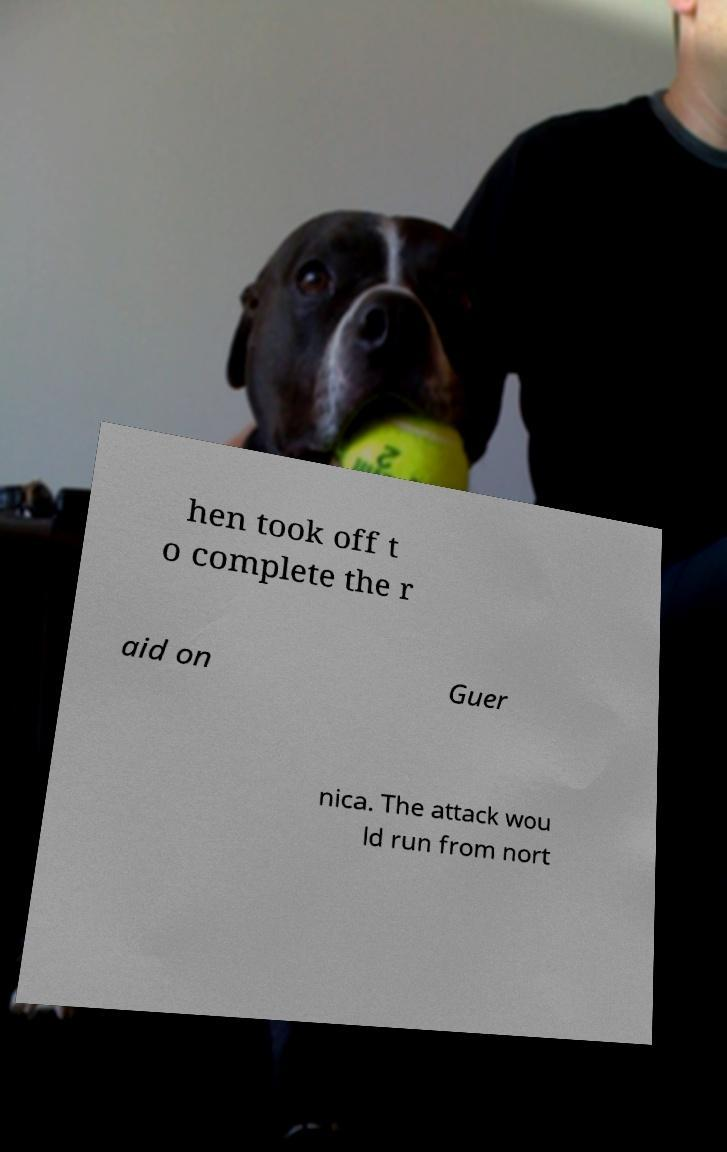Could you assist in decoding the text presented in this image and type it out clearly? hen took off t o complete the r aid on Guer nica. The attack wou ld run from nort 